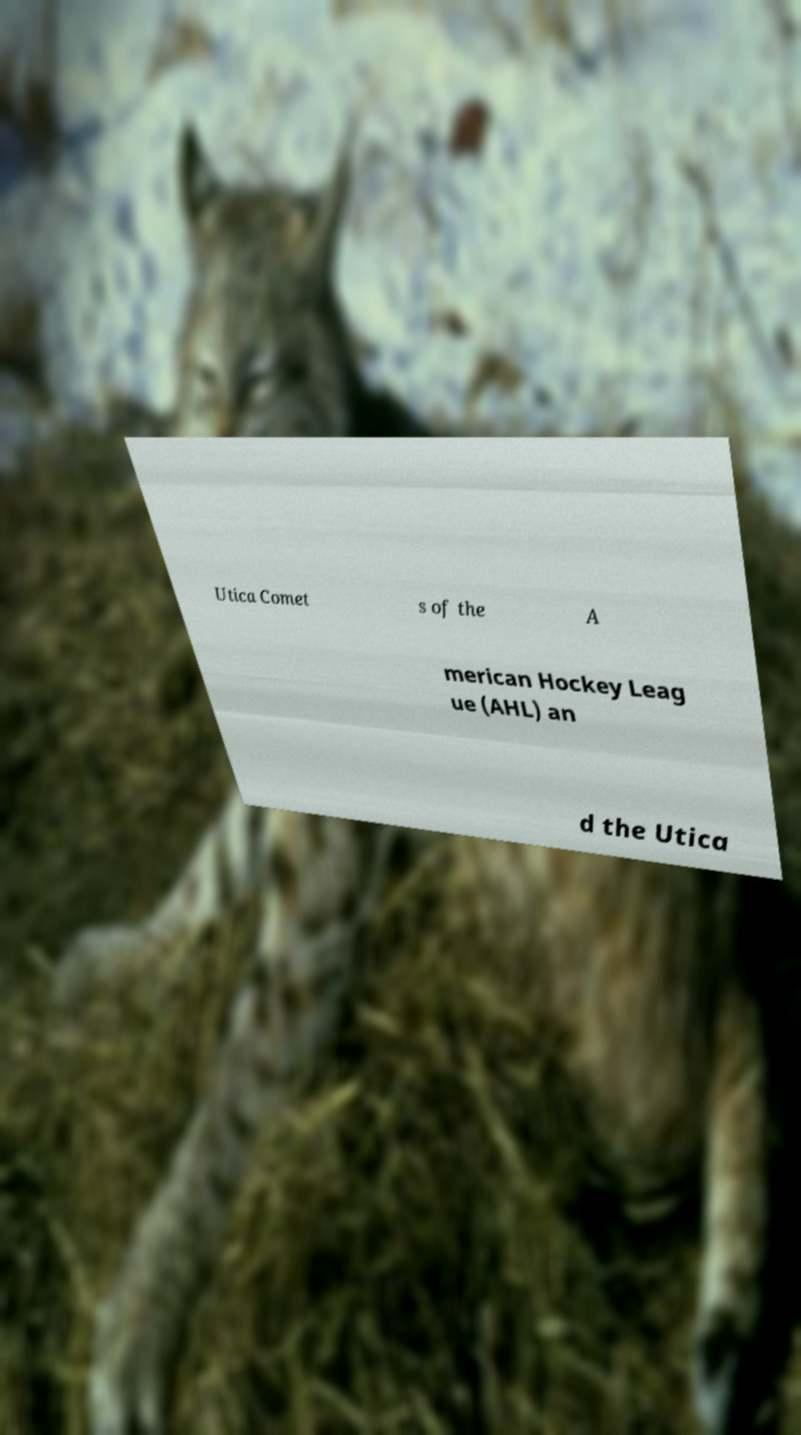I need the written content from this picture converted into text. Can you do that? Utica Comet s of the A merican Hockey Leag ue (AHL) an d the Utica 